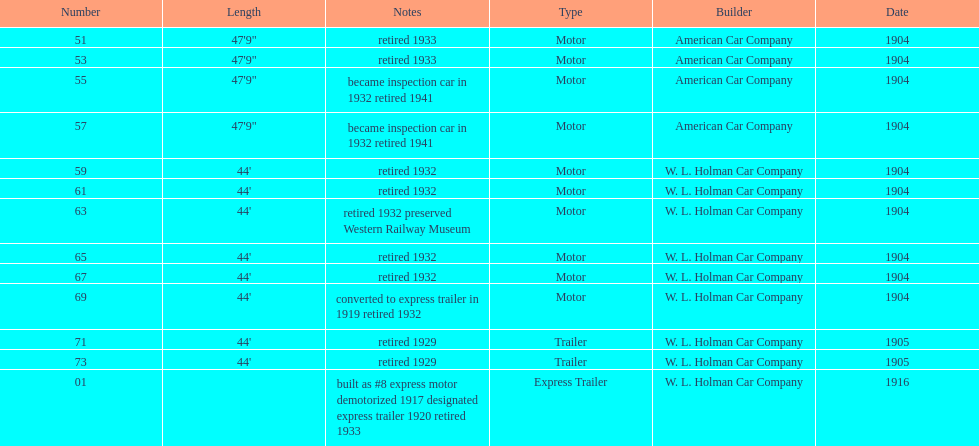In 1906, how many total rolling stock vehicles were in service? 12. 